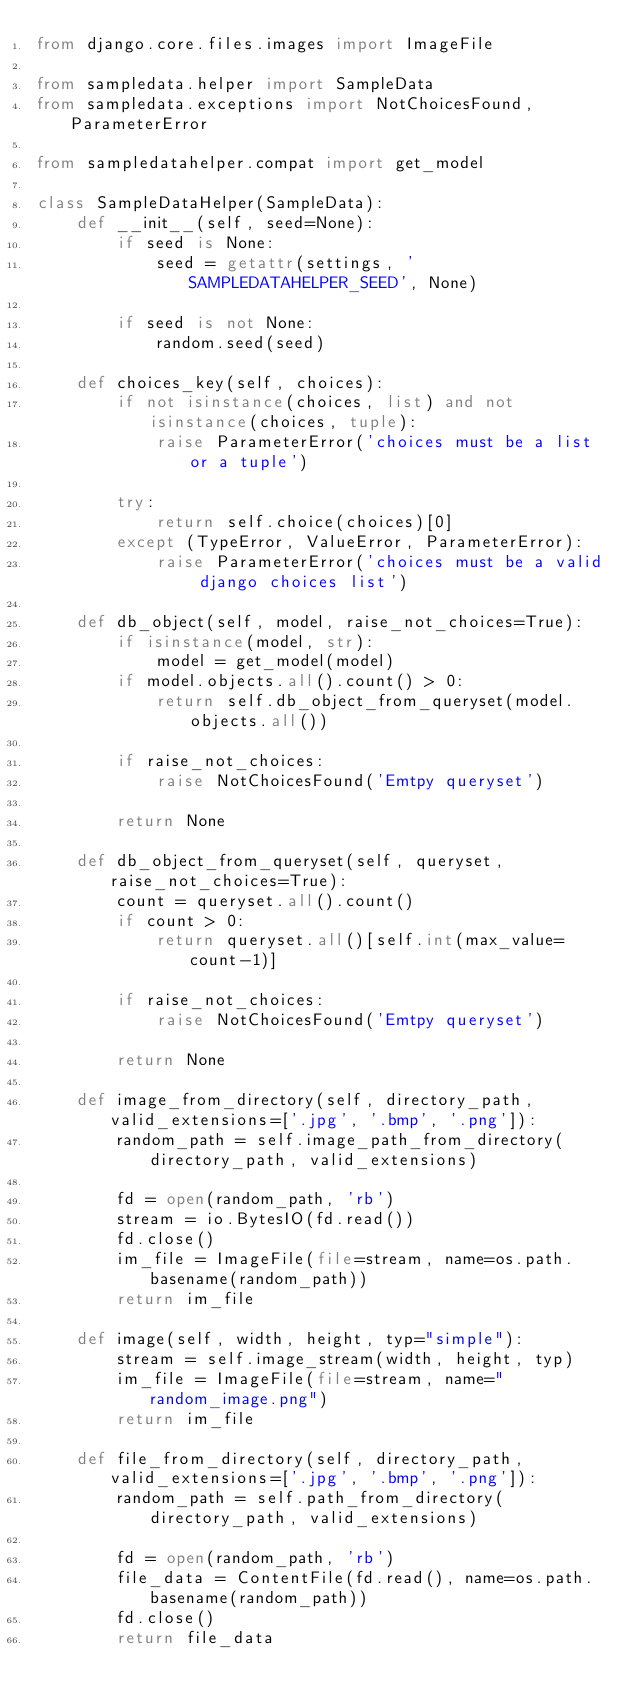Convert code to text. <code><loc_0><loc_0><loc_500><loc_500><_Python_>from django.core.files.images import ImageFile

from sampledata.helper import SampleData
from sampledata.exceptions import NotChoicesFound, ParameterError

from sampledatahelper.compat import get_model

class SampleDataHelper(SampleData):
    def __init__(self, seed=None):
        if seed is None:
            seed = getattr(settings, 'SAMPLEDATAHELPER_SEED', None)

        if seed is not None:
            random.seed(seed)

    def choices_key(self, choices):
        if not isinstance(choices, list) and not isinstance(choices, tuple):
            raise ParameterError('choices must be a list or a tuple')

        try:
            return self.choice(choices)[0]
        except (TypeError, ValueError, ParameterError):
            raise ParameterError('choices must be a valid django choices list')

    def db_object(self, model, raise_not_choices=True):
        if isinstance(model, str):
            model = get_model(model)
        if model.objects.all().count() > 0:
            return self.db_object_from_queryset(model.objects.all())

        if raise_not_choices:
            raise NotChoicesFound('Emtpy queryset')

        return None

    def db_object_from_queryset(self, queryset, raise_not_choices=True):
        count = queryset.all().count()
        if count > 0:
            return queryset.all()[self.int(max_value=count-1)]

        if raise_not_choices:
            raise NotChoicesFound('Emtpy queryset')

        return None

    def image_from_directory(self, directory_path, valid_extensions=['.jpg', '.bmp', '.png']):
        random_path = self.image_path_from_directory(directory_path, valid_extensions)

        fd = open(random_path, 'rb')
        stream = io.BytesIO(fd.read())
        fd.close()
        im_file = ImageFile(file=stream, name=os.path.basename(random_path))
        return im_file

    def image(self, width, height, typ="simple"):
        stream = self.image_stream(width, height, typ)
        im_file = ImageFile(file=stream, name="random_image.png")
        return im_file

    def file_from_directory(self, directory_path, valid_extensions=['.jpg', '.bmp', '.png']):
        random_path = self.path_from_directory(directory_path, valid_extensions)

        fd = open(random_path, 'rb')
        file_data = ContentFile(fd.read(), name=os.path.basename(random_path))
        fd.close()
        return file_data
</code> 